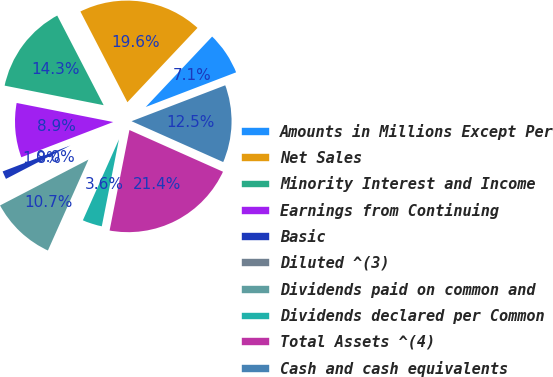<chart> <loc_0><loc_0><loc_500><loc_500><pie_chart><fcel>Amounts in Millions Except Per<fcel>Net Sales<fcel>Minority Interest and Income<fcel>Earnings from Continuing<fcel>Basic<fcel>Diluted ^(3)<fcel>Dividends paid on common and<fcel>Dividends declared per Common<fcel>Total Assets ^(4)<fcel>Cash and cash equivalents<nl><fcel>7.14%<fcel>19.64%<fcel>14.29%<fcel>8.93%<fcel>1.79%<fcel>0.0%<fcel>10.71%<fcel>3.57%<fcel>21.43%<fcel>12.5%<nl></chart> 